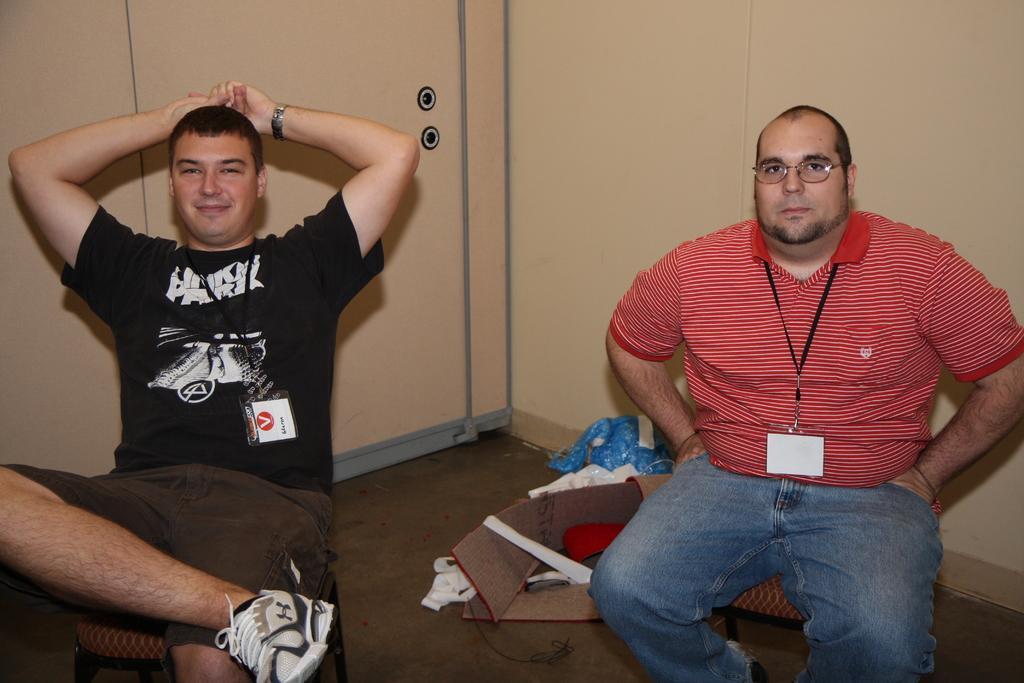Describe this image in one or two sentences. In this picture we can observe two men sitting in the chairs. Both are wearing t-shirts. One of them is wearing spectacles. We can observe cream color wall in the background. 